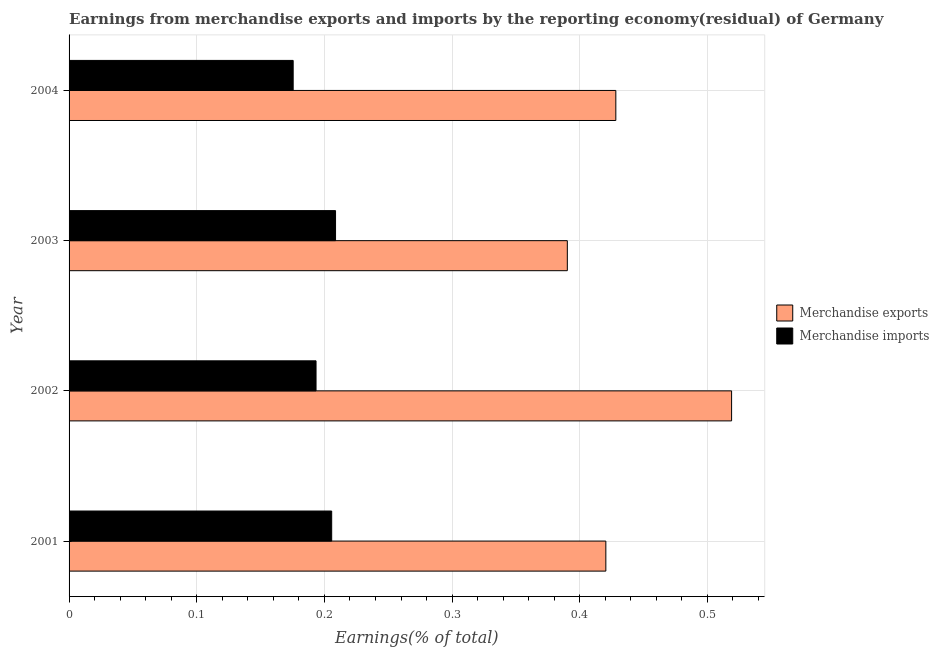How many different coloured bars are there?
Ensure brevity in your answer.  2. How many groups of bars are there?
Offer a very short reply. 4. Are the number of bars per tick equal to the number of legend labels?
Provide a short and direct response. Yes. How many bars are there on the 1st tick from the top?
Make the answer very short. 2. What is the label of the 1st group of bars from the top?
Ensure brevity in your answer.  2004. In how many cases, is the number of bars for a given year not equal to the number of legend labels?
Offer a terse response. 0. What is the earnings from merchandise imports in 2002?
Offer a terse response. 0.19. Across all years, what is the maximum earnings from merchandise exports?
Provide a short and direct response. 0.52. Across all years, what is the minimum earnings from merchandise exports?
Keep it short and to the point. 0.39. In which year was the earnings from merchandise exports maximum?
Offer a very short reply. 2002. What is the total earnings from merchandise imports in the graph?
Your answer should be compact. 0.78. What is the difference between the earnings from merchandise exports in 2001 and that in 2003?
Your answer should be very brief. 0.03. What is the difference between the earnings from merchandise imports in 2002 and the earnings from merchandise exports in 2004?
Offer a terse response. -0.23. What is the average earnings from merchandise imports per year?
Ensure brevity in your answer.  0.2. In the year 2001, what is the difference between the earnings from merchandise imports and earnings from merchandise exports?
Make the answer very short. -0.21. What is the ratio of the earnings from merchandise imports in 2001 to that in 2004?
Offer a very short reply. 1.17. What is the difference between the highest and the second highest earnings from merchandise exports?
Your answer should be compact. 0.09. Is the sum of the earnings from merchandise imports in 2002 and 2004 greater than the maximum earnings from merchandise exports across all years?
Keep it short and to the point. No. What does the 2nd bar from the bottom in 2002 represents?
Offer a terse response. Merchandise imports. How many bars are there?
Make the answer very short. 8. Are all the bars in the graph horizontal?
Offer a very short reply. Yes. How many years are there in the graph?
Make the answer very short. 4. What is the difference between two consecutive major ticks on the X-axis?
Your answer should be very brief. 0.1. Does the graph contain any zero values?
Your answer should be very brief. No. Does the graph contain grids?
Your answer should be compact. Yes. Where does the legend appear in the graph?
Offer a very short reply. Center right. How many legend labels are there?
Your response must be concise. 2. How are the legend labels stacked?
Your response must be concise. Vertical. What is the title of the graph?
Keep it short and to the point. Earnings from merchandise exports and imports by the reporting economy(residual) of Germany. Does "Female" appear as one of the legend labels in the graph?
Offer a terse response. No. What is the label or title of the X-axis?
Give a very brief answer. Earnings(% of total). What is the Earnings(% of total) in Merchandise exports in 2001?
Your answer should be very brief. 0.42. What is the Earnings(% of total) in Merchandise imports in 2001?
Give a very brief answer. 0.21. What is the Earnings(% of total) in Merchandise exports in 2002?
Provide a succinct answer. 0.52. What is the Earnings(% of total) in Merchandise imports in 2002?
Your answer should be very brief. 0.19. What is the Earnings(% of total) of Merchandise exports in 2003?
Provide a short and direct response. 0.39. What is the Earnings(% of total) in Merchandise imports in 2003?
Your response must be concise. 0.21. What is the Earnings(% of total) of Merchandise exports in 2004?
Keep it short and to the point. 0.43. What is the Earnings(% of total) in Merchandise imports in 2004?
Provide a short and direct response. 0.18. Across all years, what is the maximum Earnings(% of total) in Merchandise exports?
Ensure brevity in your answer.  0.52. Across all years, what is the maximum Earnings(% of total) of Merchandise imports?
Give a very brief answer. 0.21. Across all years, what is the minimum Earnings(% of total) in Merchandise exports?
Provide a short and direct response. 0.39. Across all years, what is the minimum Earnings(% of total) in Merchandise imports?
Keep it short and to the point. 0.18. What is the total Earnings(% of total) of Merchandise exports in the graph?
Your response must be concise. 1.76. What is the total Earnings(% of total) of Merchandise imports in the graph?
Your response must be concise. 0.78. What is the difference between the Earnings(% of total) in Merchandise exports in 2001 and that in 2002?
Your answer should be compact. -0.1. What is the difference between the Earnings(% of total) in Merchandise imports in 2001 and that in 2002?
Provide a short and direct response. 0.01. What is the difference between the Earnings(% of total) of Merchandise exports in 2001 and that in 2003?
Offer a terse response. 0.03. What is the difference between the Earnings(% of total) of Merchandise imports in 2001 and that in 2003?
Your answer should be very brief. -0. What is the difference between the Earnings(% of total) of Merchandise exports in 2001 and that in 2004?
Provide a short and direct response. -0.01. What is the difference between the Earnings(% of total) in Merchandise imports in 2001 and that in 2004?
Your response must be concise. 0.03. What is the difference between the Earnings(% of total) in Merchandise exports in 2002 and that in 2003?
Your answer should be compact. 0.13. What is the difference between the Earnings(% of total) in Merchandise imports in 2002 and that in 2003?
Provide a short and direct response. -0.02. What is the difference between the Earnings(% of total) of Merchandise exports in 2002 and that in 2004?
Make the answer very short. 0.09. What is the difference between the Earnings(% of total) of Merchandise imports in 2002 and that in 2004?
Offer a very short reply. 0.02. What is the difference between the Earnings(% of total) of Merchandise exports in 2003 and that in 2004?
Your answer should be very brief. -0.04. What is the difference between the Earnings(% of total) of Merchandise imports in 2003 and that in 2004?
Provide a short and direct response. 0.03. What is the difference between the Earnings(% of total) in Merchandise exports in 2001 and the Earnings(% of total) in Merchandise imports in 2002?
Make the answer very short. 0.23. What is the difference between the Earnings(% of total) of Merchandise exports in 2001 and the Earnings(% of total) of Merchandise imports in 2003?
Your answer should be very brief. 0.21. What is the difference between the Earnings(% of total) of Merchandise exports in 2001 and the Earnings(% of total) of Merchandise imports in 2004?
Provide a short and direct response. 0.24. What is the difference between the Earnings(% of total) of Merchandise exports in 2002 and the Earnings(% of total) of Merchandise imports in 2003?
Offer a terse response. 0.31. What is the difference between the Earnings(% of total) in Merchandise exports in 2002 and the Earnings(% of total) in Merchandise imports in 2004?
Provide a succinct answer. 0.34. What is the difference between the Earnings(% of total) in Merchandise exports in 2003 and the Earnings(% of total) in Merchandise imports in 2004?
Your answer should be compact. 0.21. What is the average Earnings(% of total) in Merchandise exports per year?
Provide a succinct answer. 0.44. What is the average Earnings(% of total) in Merchandise imports per year?
Your answer should be compact. 0.2. In the year 2001, what is the difference between the Earnings(% of total) of Merchandise exports and Earnings(% of total) of Merchandise imports?
Your answer should be very brief. 0.21. In the year 2002, what is the difference between the Earnings(% of total) of Merchandise exports and Earnings(% of total) of Merchandise imports?
Ensure brevity in your answer.  0.33. In the year 2003, what is the difference between the Earnings(% of total) in Merchandise exports and Earnings(% of total) in Merchandise imports?
Give a very brief answer. 0.18. In the year 2004, what is the difference between the Earnings(% of total) in Merchandise exports and Earnings(% of total) in Merchandise imports?
Give a very brief answer. 0.25. What is the ratio of the Earnings(% of total) in Merchandise exports in 2001 to that in 2002?
Provide a succinct answer. 0.81. What is the ratio of the Earnings(% of total) in Merchandise imports in 2001 to that in 2002?
Offer a very short reply. 1.06. What is the ratio of the Earnings(% of total) in Merchandise exports in 2001 to that in 2003?
Make the answer very short. 1.08. What is the ratio of the Earnings(% of total) in Merchandise imports in 2001 to that in 2003?
Offer a very short reply. 0.99. What is the ratio of the Earnings(% of total) of Merchandise exports in 2001 to that in 2004?
Make the answer very short. 0.98. What is the ratio of the Earnings(% of total) of Merchandise imports in 2001 to that in 2004?
Your answer should be compact. 1.17. What is the ratio of the Earnings(% of total) of Merchandise exports in 2002 to that in 2003?
Make the answer very short. 1.33. What is the ratio of the Earnings(% of total) in Merchandise imports in 2002 to that in 2003?
Give a very brief answer. 0.93. What is the ratio of the Earnings(% of total) in Merchandise exports in 2002 to that in 2004?
Provide a short and direct response. 1.21. What is the ratio of the Earnings(% of total) in Merchandise imports in 2002 to that in 2004?
Offer a terse response. 1.1. What is the ratio of the Earnings(% of total) in Merchandise exports in 2003 to that in 2004?
Give a very brief answer. 0.91. What is the ratio of the Earnings(% of total) in Merchandise imports in 2003 to that in 2004?
Your answer should be compact. 1.19. What is the difference between the highest and the second highest Earnings(% of total) in Merchandise exports?
Offer a very short reply. 0.09. What is the difference between the highest and the second highest Earnings(% of total) in Merchandise imports?
Offer a very short reply. 0. What is the difference between the highest and the lowest Earnings(% of total) in Merchandise exports?
Your answer should be compact. 0.13. What is the difference between the highest and the lowest Earnings(% of total) in Merchandise imports?
Provide a succinct answer. 0.03. 